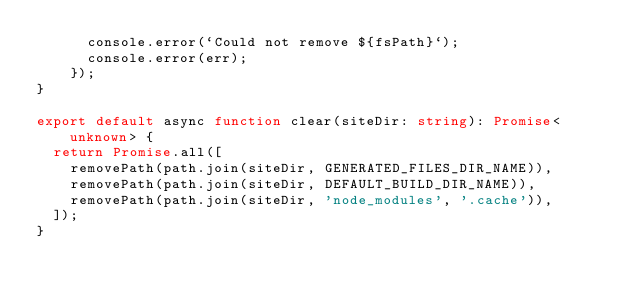<code> <loc_0><loc_0><loc_500><loc_500><_TypeScript_>      console.error(`Could not remove ${fsPath}`);
      console.error(err);
    });
}

export default async function clear(siteDir: string): Promise<unknown> {
  return Promise.all([
    removePath(path.join(siteDir, GENERATED_FILES_DIR_NAME)),
    removePath(path.join(siteDir, DEFAULT_BUILD_DIR_NAME)),
    removePath(path.join(siteDir, 'node_modules', '.cache')),
  ]);
}
</code> 